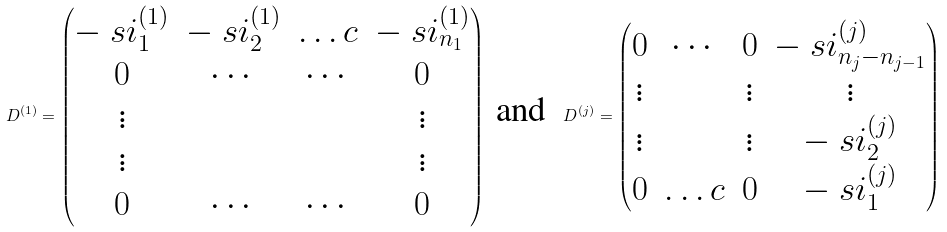Convert formula to latex. <formula><loc_0><loc_0><loc_500><loc_500>D ^ { ( 1 ) } = \begin{pmatrix} - \ s i ^ { ( 1 ) } _ { 1 } & - \ s i ^ { ( 1 ) } _ { 2 } & \dots c & - \ s i ^ { ( 1 ) } _ { n _ { 1 } } \\ 0 & \cdots & \cdots & 0 \\ \vdots & & & \vdots \\ \vdots & & & \vdots \\ 0 & \cdots & \cdots & 0 \end{pmatrix} \ \text {and} \ \ D ^ { ( j ) } = \begin{pmatrix} 0 & \cdots & 0 & - \ s i ^ { ( j ) } _ { n _ { j } - n _ { j - 1 } } \\ \vdots & & \vdots & \vdots \\ \vdots & & \vdots & - \ s i ^ { ( j ) } _ { 2 } \\ 0 & \dots c & 0 & - \ s i ^ { ( j ) } _ { 1 } \end{pmatrix}</formula> 